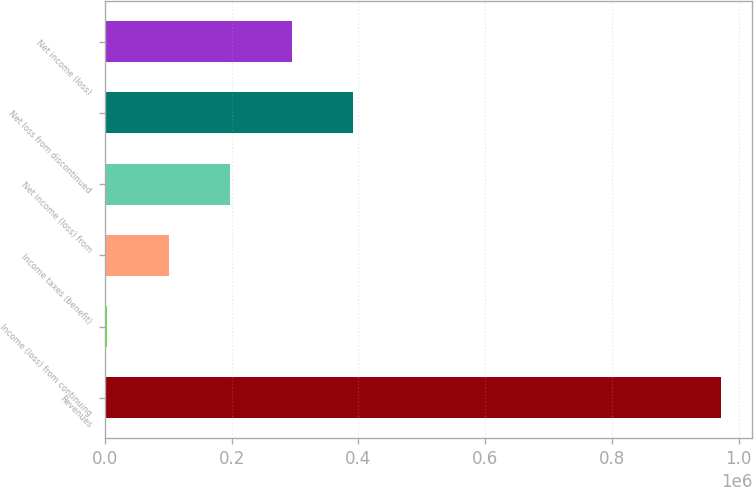Convert chart to OTSL. <chart><loc_0><loc_0><loc_500><loc_500><bar_chart><fcel>Revenues<fcel>Income (loss) from continuing<fcel>Income taxes (benefit)<fcel>Net income (loss) from<fcel>Net loss from discontinued<fcel>Net income (loss)<nl><fcel>972611<fcel>4119<fcel>100968<fcel>197817<fcel>391516<fcel>294667<nl></chart> 